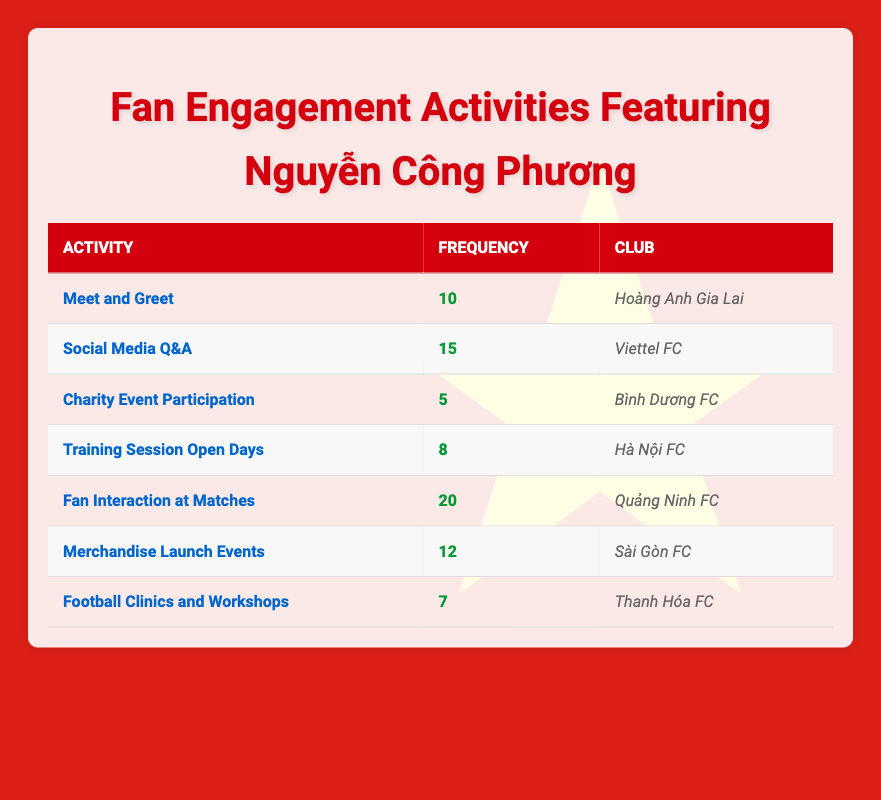What is the frequency of "Fan Interaction at Matches"? The table lists "Fan Interaction at Matches" under the activity column with a corresponding frequency of 20. Therefore, the answer can be retrieved directly from the table.
Answer: 20 Which club has the highest frequency for fan engagement activities? By examining the frequencies of all activities, "Fan Interaction at Matches" at "Quảng Ninh FC" has the highest frequency with 20. Thus, this club is identified as having the highest frequency of fan engagement.
Answer: Quảng Ninh FC What is the total frequency of fan engagement activities for all clubs in the table? To find the total frequency, sum all the individual frequencies: 10 + 15 + 5 + 8 + 20 + 12 + 7 = 77. This provides a single value that represents the overall engagement across all activities.
Answer: 77 Which activity has the lowest frequency and what is that frequency? By comparing all the frequencies listed in the table, "Charity Event Participation" has the lowest frequency at 5. This is validated by checking the frequency values provided.
Answer: 5 Is "Sài Gòn FC" involved in fan engagement activities with a frequency higher than 10? Looking at the frequency for "Merchandise Launch Events" associated with "Sài Gòn FC," it shows a frequency of 12. Since 12 is greater than 10, this makes the statement true.
Answer: Yes What is the average frequency of fan engagement activities listed in the table? To calculate the average, first sum the frequencies (77 as previously calculated) and then divide by the number of activities (7), yielding 77/7 = 11. Therefore, the average frequency is determined through these steps.
Answer: 11 How many clubs have fan engagement activities with a frequency of 10 or more? By reviewing the table, the activities with frequencies of 10 or more are "Meet and Greet" (10), "Social Media Q&A" (15), "Fan Interaction at Matches" (20), "Merchandise Launch Events" (12). This sums to four clubs, indicating the number of clubs meeting this criterion.
Answer: 4 Is it true that "Thanh Hóa FC" has a fan engagement activity frequency less than 10? The table shows "Football Clinics and Workshops," which has a frequency of 7 for "Thanh Hóa FC." Since 7 is indeed less than 10, the statement is accurate.
Answer: Yes 